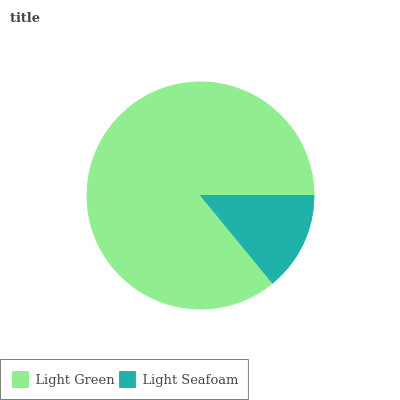Is Light Seafoam the minimum?
Answer yes or no. Yes. Is Light Green the maximum?
Answer yes or no. Yes. Is Light Seafoam the maximum?
Answer yes or no. No. Is Light Green greater than Light Seafoam?
Answer yes or no. Yes. Is Light Seafoam less than Light Green?
Answer yes or no. Yes. Is Light Seafoam greater than Light Green?
Answer yes or no. No. Is Light Green less than Light Seafoam?
Answer yes or no. No. Is Light Green the high median?
Answer yes or no. Yes. Is Light Seafoam the low median?
Answer yes or no. Yes. Is Light Seafoam the high median?
Answer yes or no. No. Is Light Green the low median?
Answer yes or no. No. 